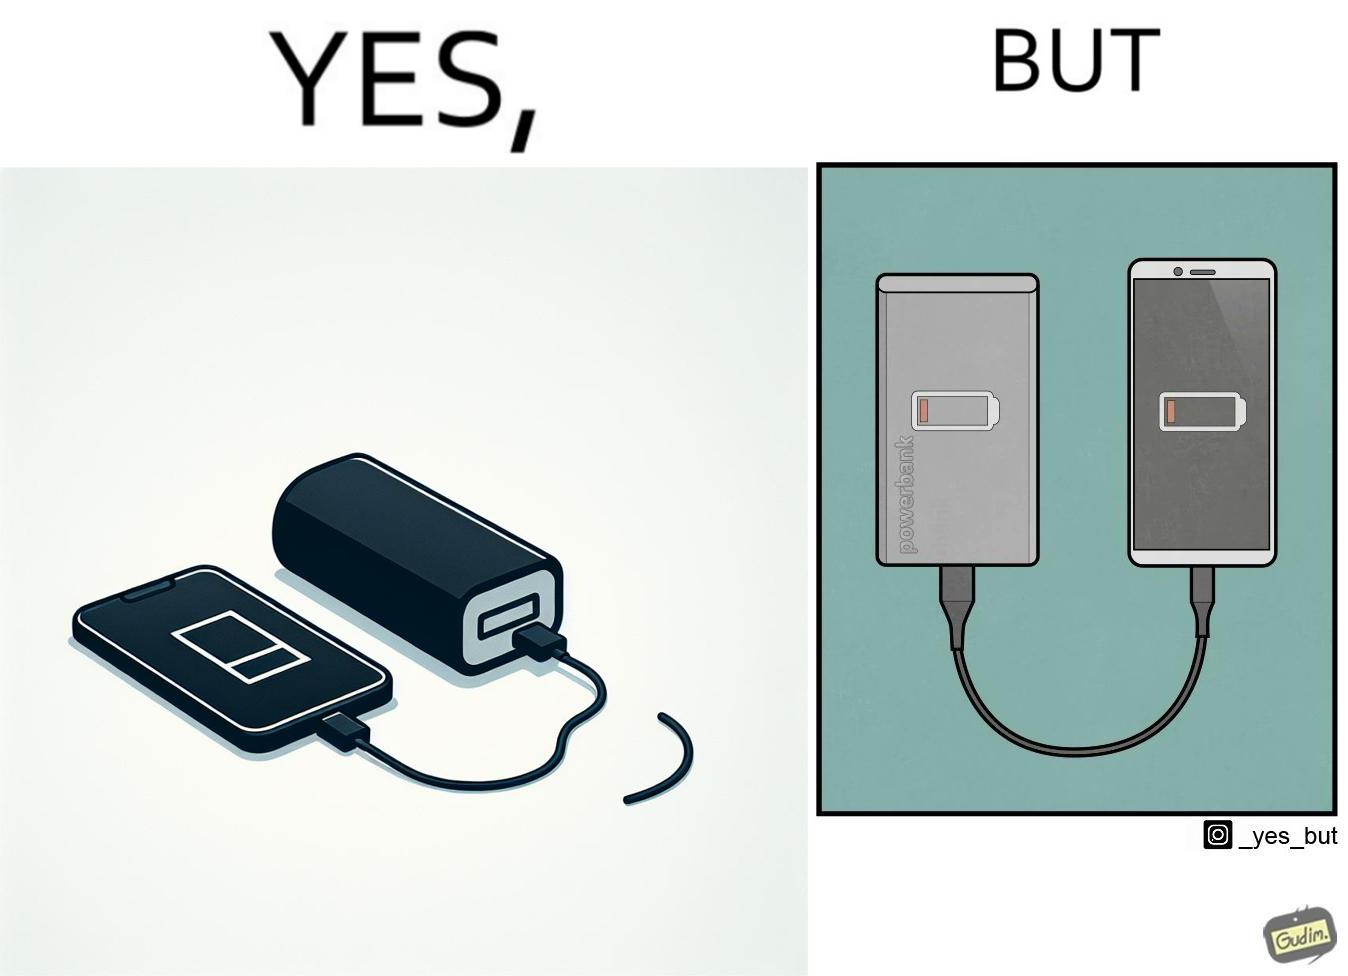Provide a description of this image. This image is funny because its an assumed expectation that  the dead phone will be rescued by the power bank, but here the power bank is also dead and of no use. 